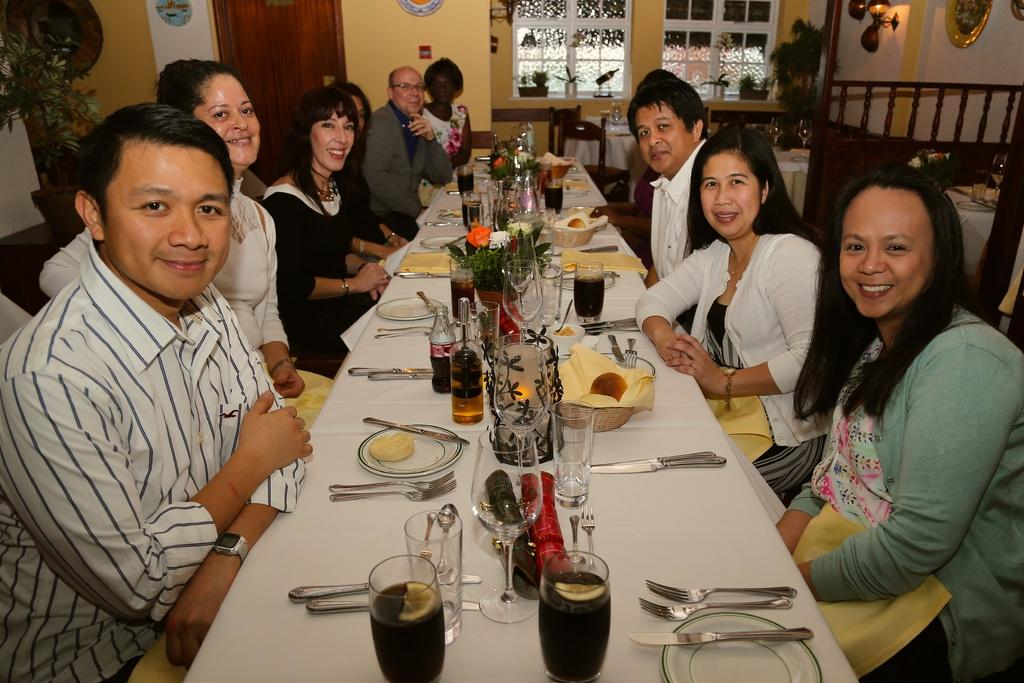How many people are in the image? There is a group of people in the image, but the exact number is not specified. What are the people doing in the image? The people are sitting around a dining table. What items can be seen on the table? There are bowls, plates, spoons, knives, glasses with drinks, and bottles on the table. How many snakes are slithering on the table in the image? There are no snakes present in the image; the table only contains bowls, plates, spoons, knives, glasses with drinks, and bottles. What is the amount of fish in the hook that is visible in the image? There is no hook or fish present in the image; it features a group of people sitting around a dining table with various items on it. 